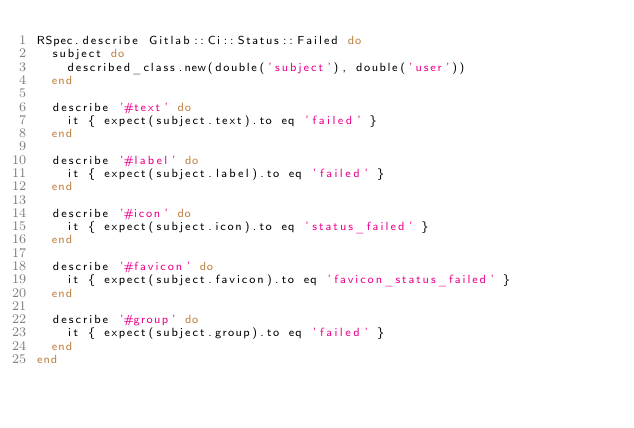Convert code to text. <code><loc_0><loc_0><loc_500><loc_500><_Ruby_>RSpec.describe Gitlab::Ci::Status::Failed do
  subject do
    described_class.new(double('subject'), double('user'))
  end

  describe '#text' do
    it { expect(subject.text).to eq 'failed' }
  end

  describe '#label' do
    it { expect(subject.label).to eq 'failed' }
  end

  describe '#icon' do
    it { expect(subject.icon).to eq 'status_failed' }
  end

  describe '#favicon' do
    it { expect(subject.favicon).to eq 'favicon_status_failed' }
  end

  describe '#group' do
    it { expect(subject.group).to eq 'failed' }
  end
end
</code> 